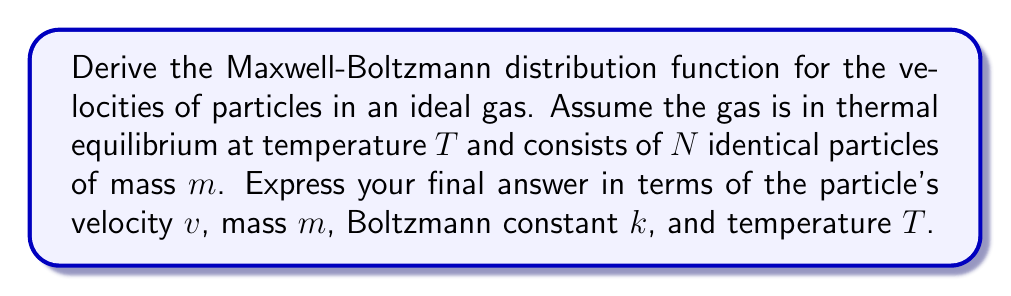Teach me how to tackle this problem. Let's approach this step-by-step:

1) We start with the Boltzmann distribution, which gives the probability of a particle being in a state with energy E:

   $$P(E) \propto e^{-E/kT}$$

2) For a particle with velocity v, its kinetic energy is:

   $$E = \frac{1}{2}mv^2$$

3) Substituting this into the Boltzmann distribution:

   $$P(v) \propto e^{-mv^2/2kT}$$

4) We need to normalize this distribution. In 3D velocity space, the number of particles with velocities between v and v + dv is proportional to the volume of a spherical shell:

   $$dN = N \cdot 4\pi v^2 \cdot f(v) \cdot dv$$

   where f(v) is our normalized distribution function.

5) The normalization condition is:

   $$\int_0^\infty 4\pi v^2 f(v) dv = 1$$

6) Using the form from step 3, we can write:

   $$f(v) = A e^{-mv^2/2kT}$$

   where A is a normalization constant.

7) Substituting this into the normalization condition:

   $$4\pi A \int_0^\infty v^2 e^{-mv^2/2kT} dv = 1$$

8) This integral can be solved using the substitution $u = mv^2/2kT$:

   $$4\pi A \left(\frac{2kT}{m}\right)^{3/2} \int_0^\infty u^{1/2} e^{-u} du = 1$$

9) The integral evaluates to $\frac{\sqrt{\pi}}{2}$, so:

   $$A = \left(\frac{m}{2\pi kT}\right)^{3/2}$$

10) Therefore, the final Maxwell-Boltzmann distribution is:

    $$f(v) = \left(\frac{m}{2\pi kT}\right)^{3/2} e^{-mv^2/2kT}$$
Answer: $$f(v) = \left(\frac{m}{2\pi kT}\right)^{3/2} e^{-mv^2/2kT}$$ 